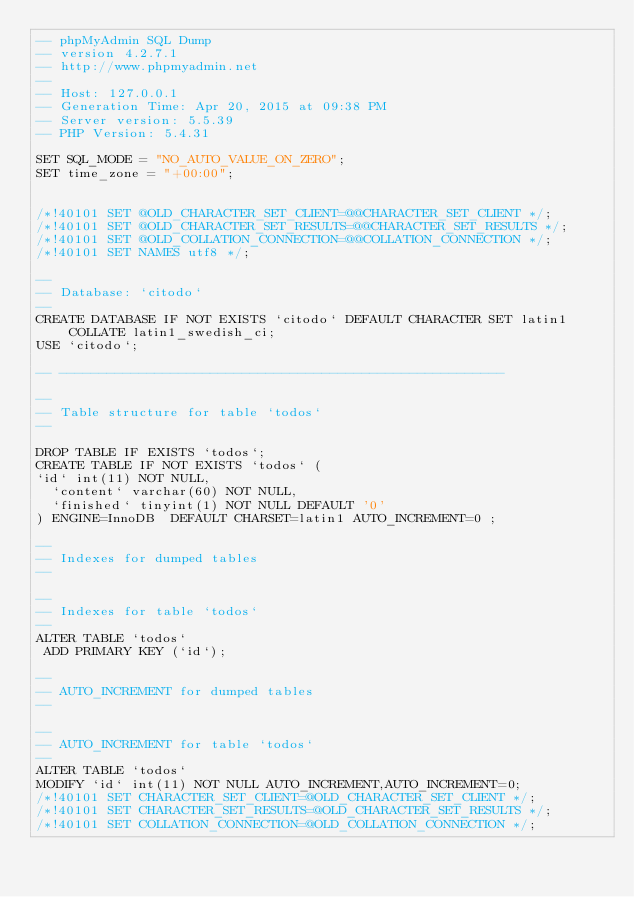Convert code to text. <code><loc_0><loc_0><loc_500><loc_500><_SQL_>-- phpMyAdmin SQL Dump
-- version 4.2.7.1
-- http://www.phpmyadmin.net
--
-- Host: 127.0.0.1
-- Generation Time: Apr 20, 2015 at 09:38 PM
-- Server version: 5.5.39
-- PHP Version: 5.4.31

SET SQL_MODE = "NO_AUTO_VALUE_ON_ZERO";
SET time_zone = "+00:00";


/*!40101 SET @OLD_CHARACTER_SET_CLIENT=@@CHARACTER_SET_CLIENT */;
/*!40101 SET @OLD_CHARACTER_SET_RESULTS=@@CHARACTER_SET_RESULTS */;
/*!40101 SET @OLD_COLLATION_CONNECTION=@@COLLATION_CONNECTION */;
/*!40101 SET NAMES utf8 */;

--
-- Database: `citodo`
--
CREATE DATABASE IF NOT EXISTS `citodo` DEFAULT CHARACTER SET latin1 COLLATE latin1_swedish_ci;
USE `citodo`;

-- --------------------------------------------------------

--
-- Table structure for table `todos`
--

DROP TABLE IF EXISTS `todos`;
CREATE TABLE IF NOT EXISTS `todos` (
`id` int(11) NOT NULL,
  `content` varchar(60) NOT NULL,
  `finished` tinyint(1) NOT NULL DEFAULT '0'
) ENGINE=InnoDB  DEFAULT CHARSET=latin1 AUTO_INCREMENT=0 ;

--
-- Indexes for dumped tables
--

--
-- Indexes for table `todos`
--
ALTER TABLE `todos`
 ADD PRIMARY KEY (`id`);

--
-- AUTO_INCREMENT for dumped tables
--

--
-- AUTO_INCREMENT for table `todos`
--
ALTER TABLE `todos`
MODIFY `id` int(11) NOT NULL AUTO_INCREMENT,AUTO_INCREMENT=0;
/*!40101 SET CHARACTER_SET_CLIENT=@OLD_CHARACTER_SET_CLIENT */;
/*!40101 SET CHARACTER_SET_RESULTS=@OLD_CHARACTER_SET_RESULTS */;
/*!40101 SET COLLATION_CONNECTION=@OLD_COLLATION_CONNECTION */;
</code> 